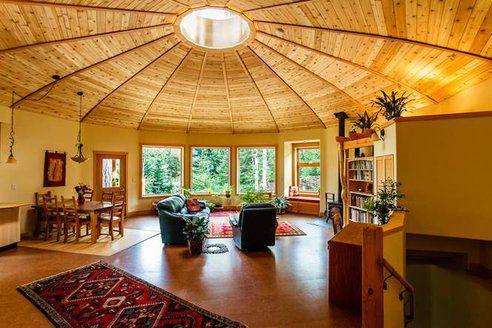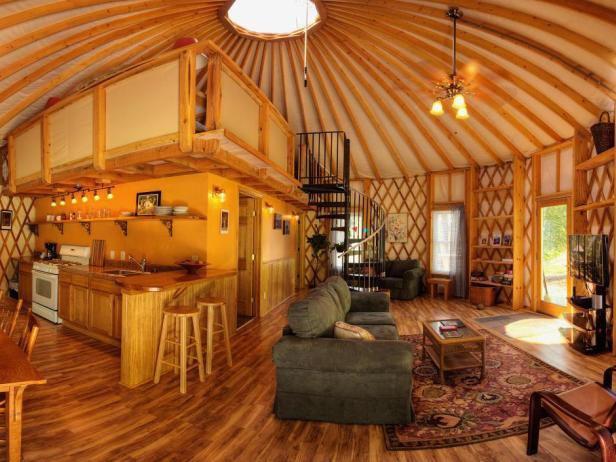The first image is the image on the left, the second image is the image on the right. Examine the images to the left and right. Is the description "There are at least two stools in one of the images." accurate? Answer yes or no. Yes. 